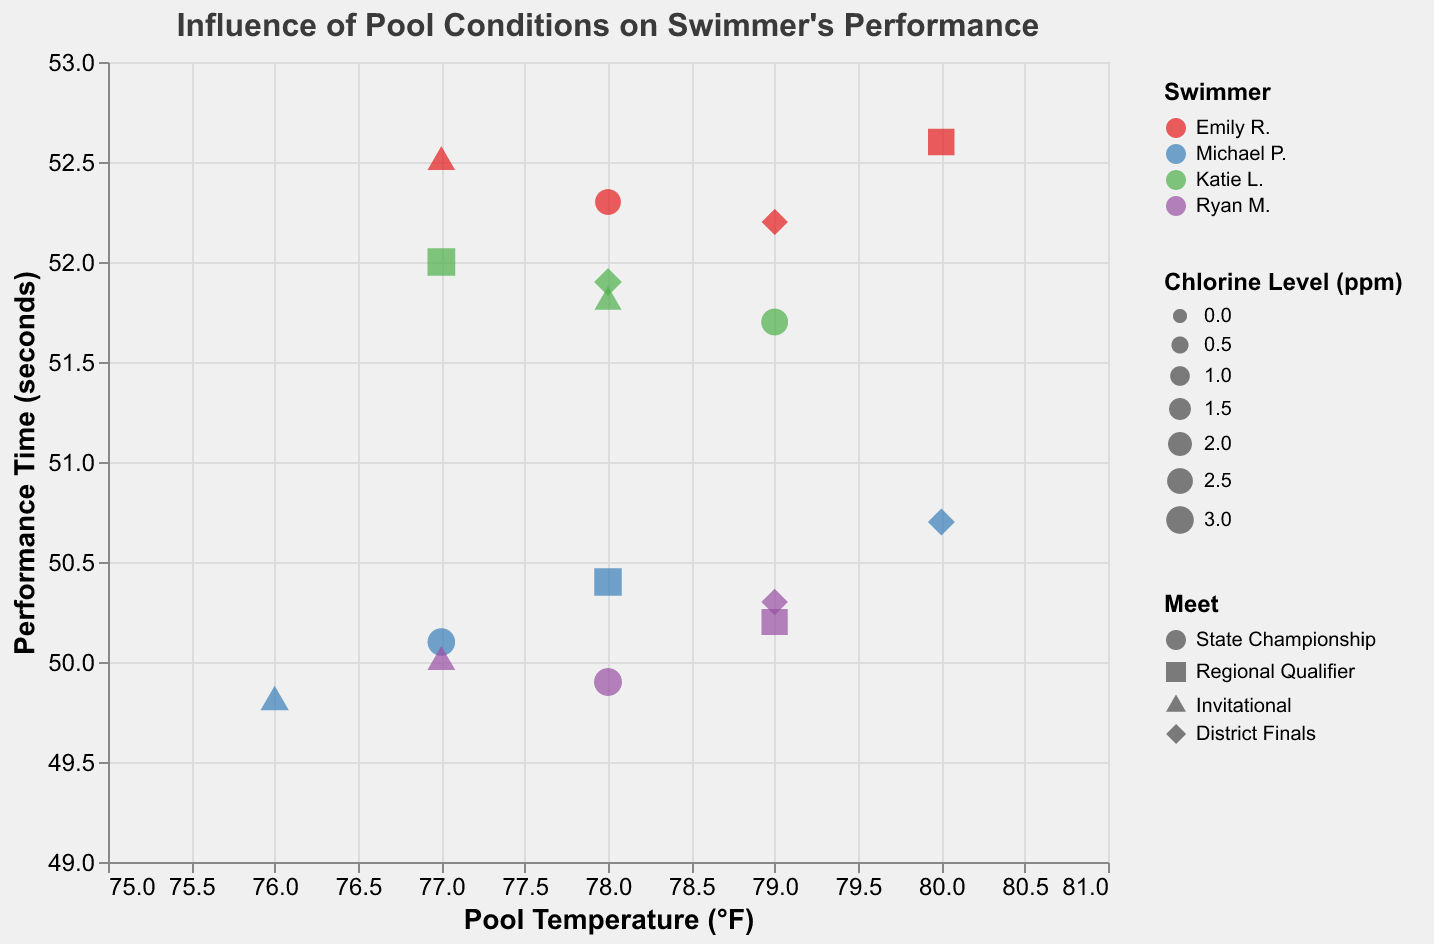How many swimmers are shown in the plot? The plot uses different colors to represent the swimmers: Emily R., Michael P., Katie L., and Ryan M. Counting the distinct colors in the legend gives us the number of swimmers.
Answer: 4 What is the performance time of Michael P. at the State Championship? Locate Michael P.'s point represented by the color blue, then find the point shaped like a circle (representing the State Championship meet) and read the corresponding y-value.
Answer: 50.1 seconds Which swimmer had the lowest performance time, and at which meet did it occur? Compare the y-values of all the points and identify the point with the lowest y-value. Check the swimmer’s color and meet’s shape associated with this point.
Answer: Michael P. at the Invitational What is the range of pool temperatures shown in the plot? Observe the x-axis to find the minimum and maximum pool temperature values that the data points cover.
Answer: 76°F to 80°F Does chlorine level impact the size of the points on the plot? Observe the legend for chlorine level and point sizes, then confirm if larger chlorine levels are represented by larger points.
Answer: Yes Which swimmer has the most consistent performance time across different meets? Examine each swimmer's points and compare the spread (variation) of their performance times. The swimmer with the least variation across different meets will have the most consistent performance.
Answer: Emily R What is the average performance time of Ryan M. across all meets? Identify Ryan M.'s points (purple color), note their performance times, and calculate the average: (49.9 + 50.2 + 50.0 + 50.3) / 4
Answer: 50.1 seconds Which meet has the highest pool temperature recorded? Look at the pool temperature (x-axis) of each meet's points and identify the highest value and the corresponding meet shape.
Answer: Regional Qualifier Is there any observable relationship between pool temperature and performance time for any swimmer? Examine the points of each swimmer individually to see patterns or trends relating pool temperature (x-axis) to performance time (y-axis).
Answer: Ryan M. seems to have a faster time as temperature increases slightly, while other swimmers show no strong trend Does Michael P. perform better in meets with higher chlorine levels? Compare Michael P.'s points (blue color) regarding chlorine levels (size) and performance times (y-axis) to determine if there's an improvement with higher chlorine levels.
Answer: Yes, he performs better with higher chlorine levels 